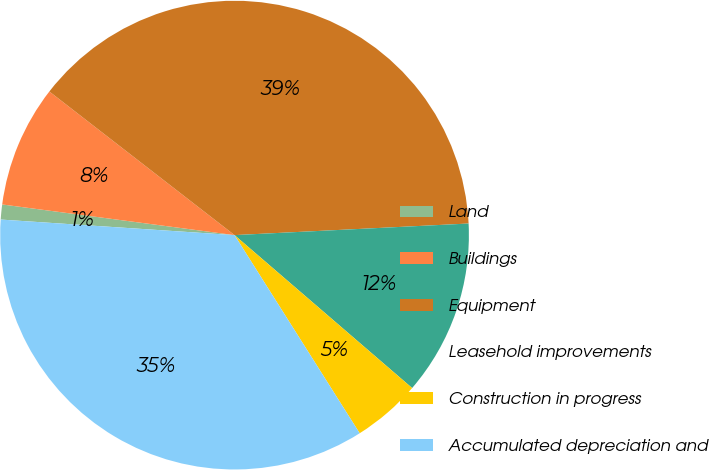Convert chart. <chart><loc_0><loc_0><loc_500><loc_500><pie_chart><fcel>Land<fcel>Buildings<fcel>Equipment<fcel>Leasehold improvements<fcel>Construction in progress<fcel>Accumulated depreciation and<nl><fcel>1.03%<fcel>8.41%<fcel>38.71%<fcel>12.1%<fcel>4.72%<fcel>35.02%<nl></chart> 